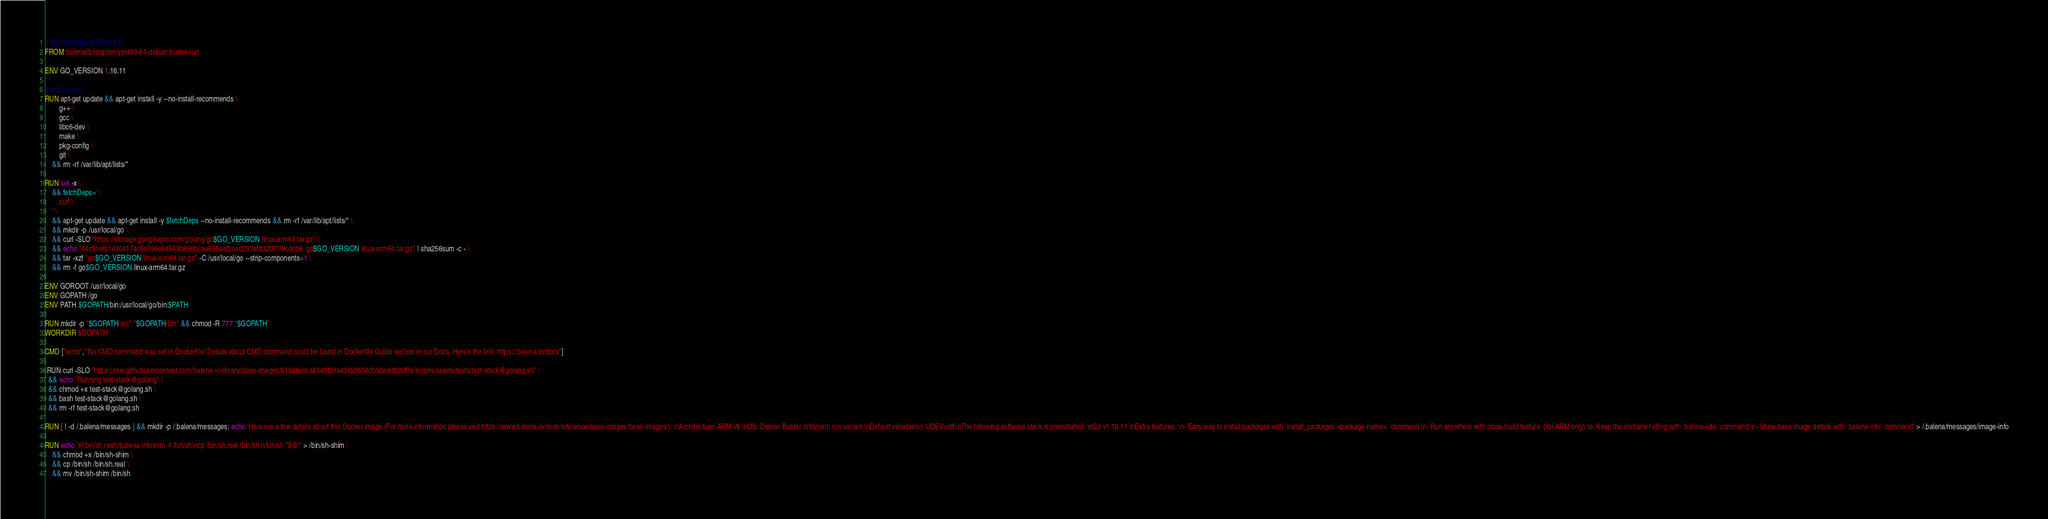Convert code to text. <code><loc_0><loc_0><loc_500><loc_500><_Dockerfile_># AUTOGENERATED FILE
FROM balenalib/raspberrypi400-64-debian:buster-run

ENV GO_VERSION 1.16.11

# gcc for cgo
RUN apt-get update && apt-get install -y --no-install-recommends \
		g++ \
		gcc \
		libc6-dev \
		make \
		pkg-config \
		git \
	&& rm -rf /var/lib/apt/lists/*

RUN set -x \
	&& fetchDeps=' \
		curl \
	' \
	&& apt-get update && apt-get install -y $fetchDeps --no-install-recommends && rm -rf /var/lib/apt/lists/* \
	&& mkdir -p /usr/local/go \
	&& curl -SLO "https://storage.googleapis.com/golang/go$GO_VERSION.linux-arm64.tar.gz" \
	&& echo "64c91efd14304174c6e796e84543b896b2ae855aaf2ce0237efd32f2079cdcb8  go$GO_VERSION.linux-arm64.tar.gz" | sha256sum -c - \
	&& tar -xzf "go$GO_VERSION.linux-arm64.tar.gz" -C /usr/local/go --strip-components=1 \
	&& rm -f go$GO_VERSION.linux-arm64.tar.gz

ENV GOROOT /usr/local/go
ENV GOPATH /go
ENV PATH $GOPATH/bin:/usr/local/go/bin:$PATH

RUN mkdir -p "$GOPATH/src" "$GOPATH/bin" && chmod -R 777 "$GOPATH"
WORKDIR $GOPATH

CMD ["echo","'No CMD command was set in Dockerfile! Details about CMD command could be found in Dockerfile Guide section in our Docs. Here's the link: https://balena.io/docs"]

 RUN curl -SLO "https://raw.githubusercontent.com/balena-io-library/base-images/613d8e9ca8540f29a43fddf658db56a8d826fffe/scripts/assets/tests/test-stack@golang.sh" \
  && echo "Running test-stack@golang" \
  && chmod +x test-stack@golang.sh \
  && bash test-stack@golang.sh \
  && rm -rf test-stack@golang.sh 

RUN [ ! -d /.balena/messages ] && mkdir -p /.balena/messages; echo 'Here are a few details about this Docker image (For more information please visit https://www.balena.io/docs/reference/base-images/base-images/): \nArchitecture: ARM v8 \nOS: Debian Buster \nVariant: run variant \nDefault variable(s): UDEV=off \nThe following software stack is preinstalled: \nGo v1.16.11 \nExtra features: \n- Easy way to install packages with `install_packages <package-name>` command \n- Run anywhere with cross-build feature  (for ARM only) \n- Keep the container idling with `balena-idle` command \n- Show base image details with `balena-info` command' > /.balena/messages/image-info

RUN echo '#!/bin/sh.real\nbalena-info\nrm -f /bin/sh\ncp /bin/sh.real /bin/sh\n/bin/sh "$@"' > /bin/sh-shim \
	&& chmod +x /bin/sh-shim \
	&& cp /bin/sh /bin/sh.real \
	&& mv /bin/sh-shim /bin/sh</code> 